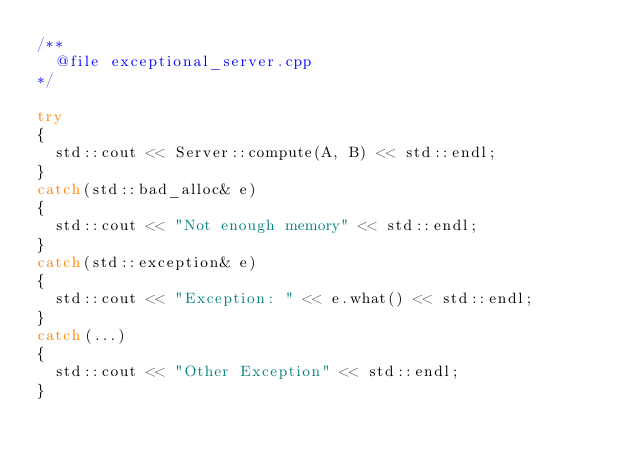<code> <loc_0><loc_0><loc_500><loc_500><_C++_>/**
	@file exceptional_server.cpp
*/

try
{
	std::cout << Server::compute(A, B) << std::endl;
}
catch(std::bad_alloc& e)
{
	std::cout << "Not enough memory" << std::endl;
}
catch(std::exception& e)
{
	std::cout << "Exception: " << e.what() << std::endl;
}
catch(...)
{
	std::cout << "Other Exception" << std::endl;
}</code> 